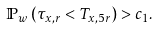Convert formula to latex. <formula><loc_0><loc_0><loc_500><loc_500>\mathbb { P } _ { w } \left ( \tau _ { x , r } < T _ { x , 5 r } \right ) > c _ { 1 } .</formula> 